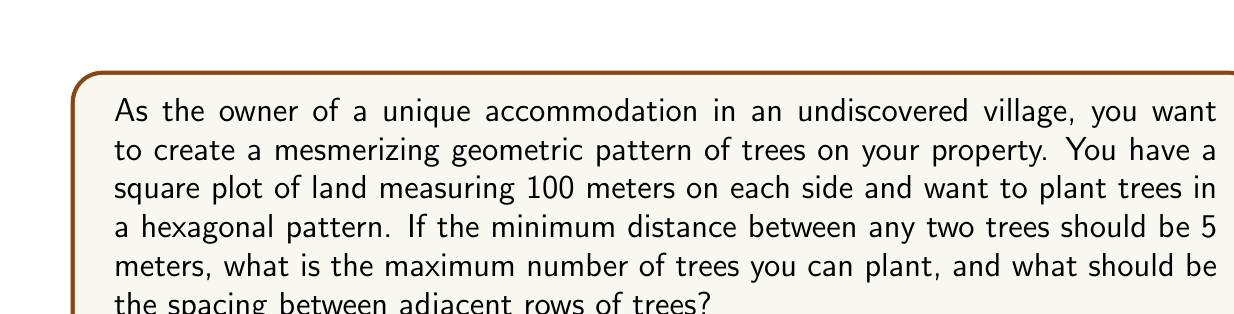Solve this math problem. Let's approach this step-by-step:

1) In a hexagonal pattern, each tree is surrounded by 6 other trees forming a regular hexagon. The centers of these trees form equilateral triangles.

2) Let the spacing between adjacent rows be $h$ meters. In an equilateral triangle, the height $h$ is related to the side length $s$ by:

   $$h = \frac{\sqrt{3}}{2}s$$

3) Given the minimum distance between trees is 5 meters, we have:

   $$5 = \frac{\sqrt{3}}{2}s$$
   $$s = \frac{10}{\sqrt{3}} \approx 5.77 \text{ meters}$$

4) The spacing between adjacent rows, $h$, is therefore:

   $$h = \frac{\sqrt{3}}{2} \cdot \frac{10}{\sqrt{3}} = 5 \text{ meters}$$

5) In a 100m x 100m square, the number of rows will be:

   $$\text{Number of rows} = \left\lfloor\frac{100}{5}\right\rfloor = 20$$

6) In odd-numbered rows, the number of trees will be:

   $$\text{Trees in odd rows} = \left\lfloor\frac{100}{5.77}\right\rfloor = 17$$

7) In even-numbered rows, trees are offset, so there will be one less:

   $$\text{Trees in even rows} = 16$$

8) Total number of trees:

   $$\text{Total trees} = 10 \cdot 17 + 10 \cdot 16 = 330$$

Therefore, you can plant a maximum of 330 trees with a spacing of 5 meters between adjacent rows.
Answer: 330 trees; 5 meters between rows 